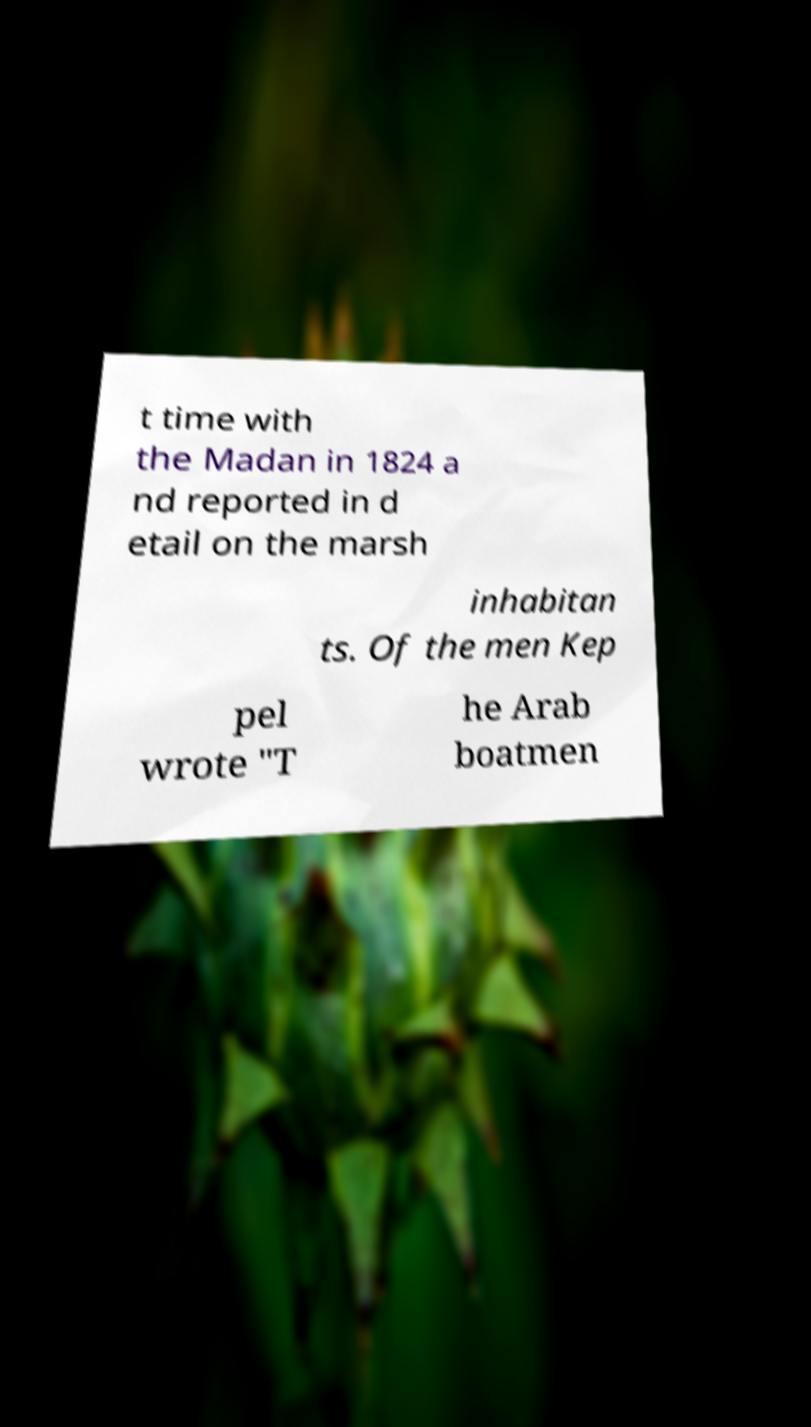Could you extract and type out the text from this image? t time with the Madan in 1824 a nd reported in d etail on the marsh inhabitan ts. Of the men Kep pel wrote "T he Arab boatmen 